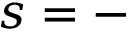Convert formula to latex. <formula><loc_0><loc_0><loc_500><loc_500>s = -</formula> 